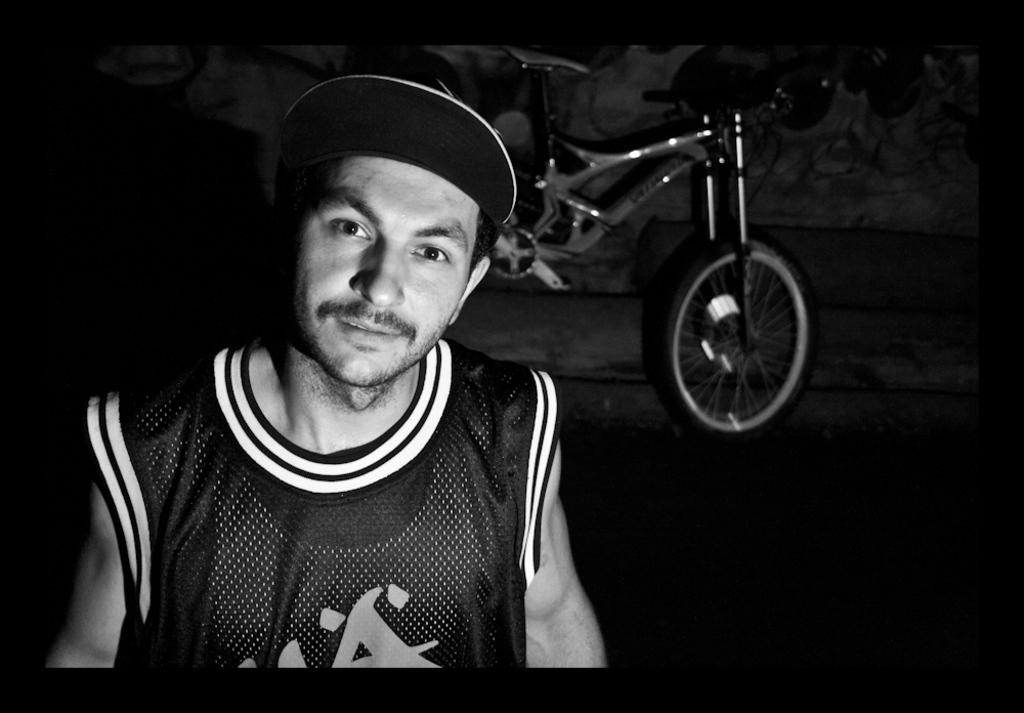What is the color scheme of the image? The image is black and white. Who is present in the image? There is a man in the image. What is the man wearing on his head? The man is wearing a cap. What can be seen in the background of the image? There is a bicycle and other objects in the background of the image. What is depicted on the wall in the background of the image? There are drawings on the wall in the background of the image. What type of wound can be seen on the man's arm in the image? There is no wound visible on the man's arm in the image. What holiday is being celebrated in the image? There is no indication of a holiday being celebrated in the image. 